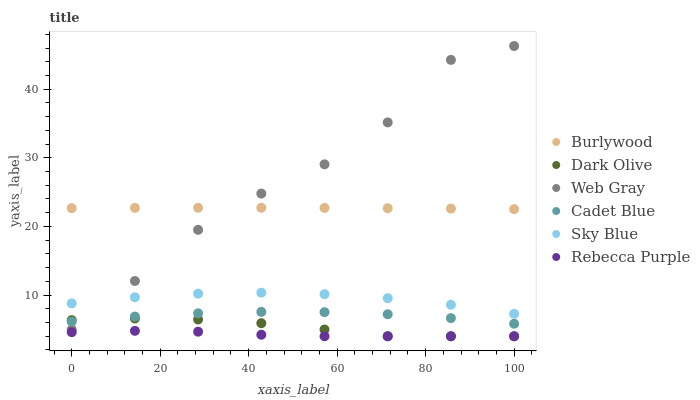Does Rebecca Purple have the minimum area under the curve?
Answer yes or no. Yes. Does Web Gray have the maximum area under the curve?
Answer yes or no. Yes. Does Burlywood have the minimum area under the curve?
Answer yes or no. No. Does Burlywood have the maximum area under the curve?
Answer yes or no. No. Is Burlywood the smoothest?
Answer yes or no. Yes. Is Web Gray the roughest?
Answer yes or no. Yes. Is Dark Olive the smoothest?
Answer yes or no. No. Is Dark Olive the roughest?
Answer yes or no. No. Does Dark Olive have the lowest value?
Answer yes or no. Yes. Does Burlywood have the lowest value?
Answer yes or no. No. Does Web Gray have the highest value?
Answer yes or no. Yes. Does Burlywood have the highest value?
Answer yes or no. No. Is Dark Olive less than Burlywood?
Answer yes or no. Yes. Is Sky Blue greater than Rebecca Purple?
Answer yes or no. Yes. Does Rebecca Purple intersect Dark Olive?
Answer yes or no. Yes. Is Rebecca Purple less than Dark Olive?
Answer yes or no. No. Is Rebecca Purple greater than Dark Olive?
Answer yes or no. No. Does Dark Olive intersect Burlywood?
Answer yes or no. No. 